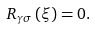<formula> <loc_0><loc_0><loc_500><loc_500>R _ { \gamma \sigma } \left ( \xi \right ) = 0 .</formula> 